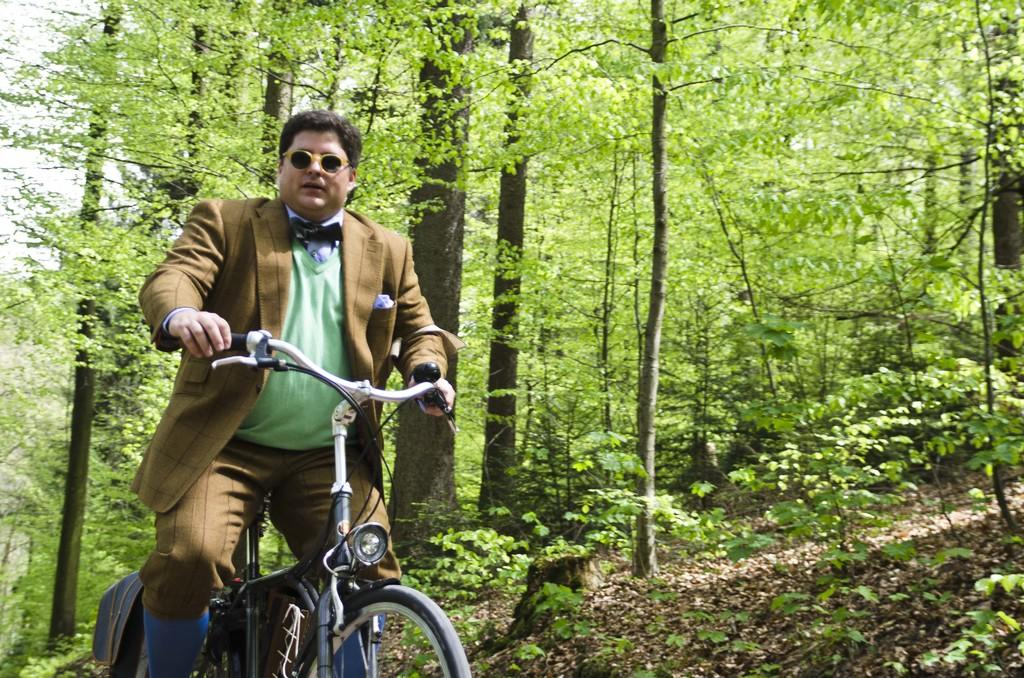What is the main subject of the image? The main subject of the image is a man. What is the man doing in the image? The man is riding a cycle in the image. What is the man wearing on his face? The man is wearing shades in the image. What can be seen in the background of the image? There are trees visible in the background of the image. How many clovers can be seen growing on the man's arm in the image? There are no clovers visible on the man's arm in the image, as the facts provided do not mention any clovers or the man's arm. 